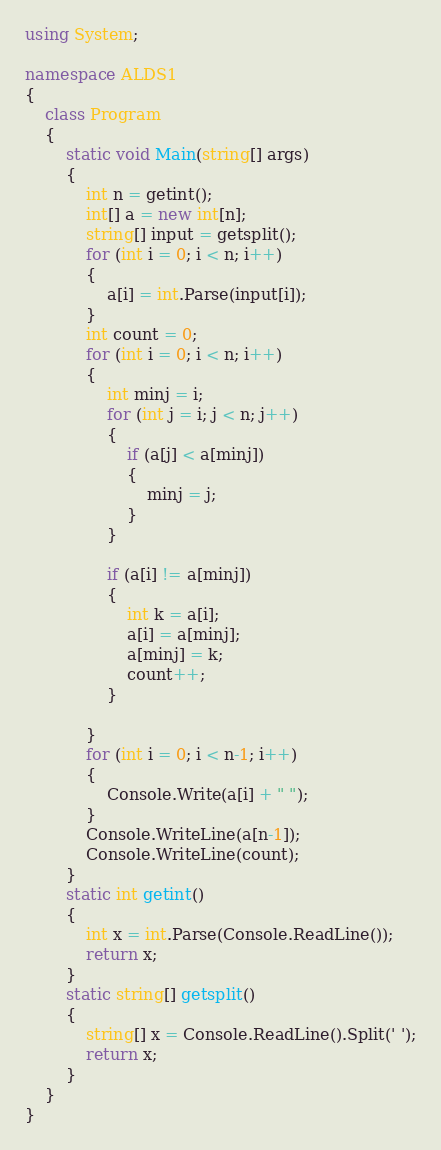Convert code to text. <code><loc_0><loc_0><loc_500><loc_500><_C#_>using System;

namespace ALDS1
{
    class Program
    {
        static void Main(string[] args)
        {
            int n = getint();
            int[] a = new int[n];
            string[] input = getsplit();
            for (int i = 0; i < n; i++)
            {
                a[i] = int.Parse(input[i]);
            }
            int count = 0;
            for (int i = 0; i < n; i++)
            {
                int minj = i;
                for (int j = i; j < n; j++)
                {
                    if (a[j] < a[minj])
                    {
                        minj = j;
                    }
                }

                if (a[i] != a[minj])
                {
                    int k = a[i];
                    a[i] = a[minj];
                    a[minj] = k;
                    count++;
                }

            }
            for (int i = 0; i < n-1; i++)
            {
                Console.Write(a[i] + " ");
            }
            Console.WriteLine(a[n-1]);
            Console.WriteLine(count);
        }
        static int getint()
        {
            int x = int.Parse(Console.ReadLine());
            return x;
        }
        static string[] getsplit()
        {
            string[] x = Console.ReadLine().Split(' ');
            return x;
        }
    }
}</code> 